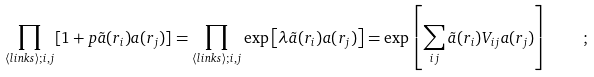Convert formula to latex. <formula><loc_0><loc_0><loc_500><loc_500>\prod _ { \langle l i n k s \rangle ; i , j } [ 1 + p { \tilde { a } } ( { r } _ { i } ) a ( { r } _ { j } ) ] = \prod _ { \langle l i n k s \rangle ; i , j } \exp \left [ \lambda { \tilde { a } } ( { r } _ { i } ) a ( { r } _ { j } ) \right ] = \exp \left [ \sum _ { i j } { \tilde { a } } ( { r } _ { i } ) V _ { i j } a ( { r } _ { j } ) \right ] \quad ;</formula> 